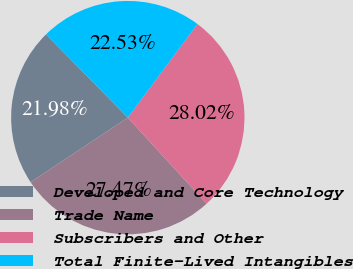Convert chart to OTSL. <chart><loc_0><loc_0><loc_500><loc_500><pie_chart><fcel>Developed and Core Technology<fcel>Trade Name<fcel>Subscribers and Other<fcel>Total Finite-Lived Intangibles<nl><fcel>21.98%<fcel>27.47%<fcel>28.02%<fcel>22.53%<nl></chart> 